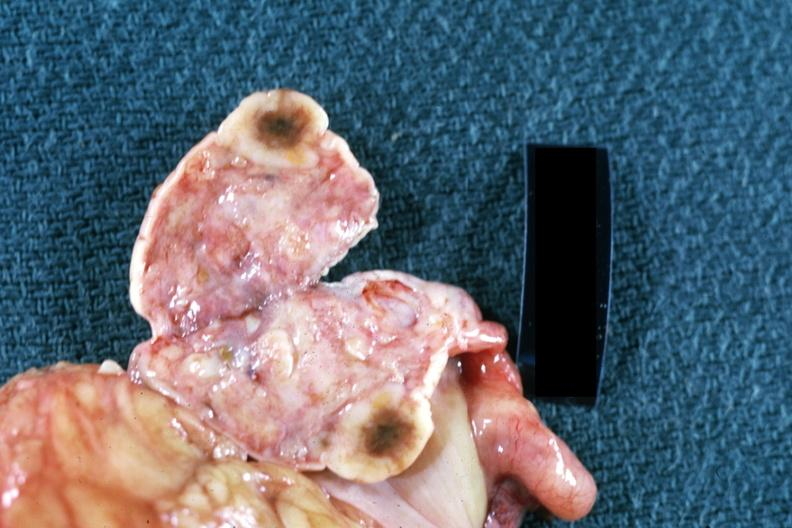s metastatic carcinoma present?
Answer the question using a single word or phrase. Yes 